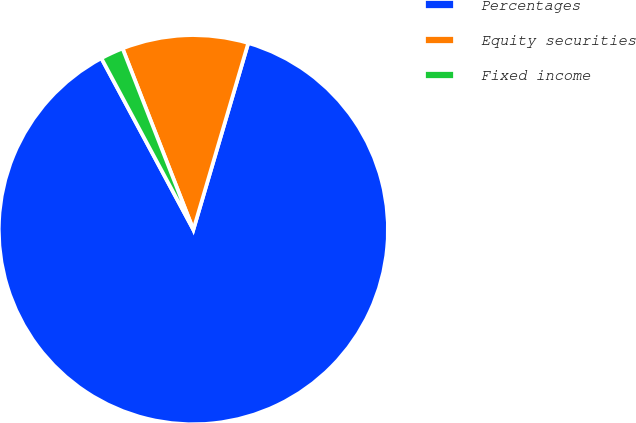Convert chart to OTSL. <chart><loc_0><loc_0><loc_500><loc_500><pie_chart><fcel>Percentages<fcel>Equity securities<fcel>Fixed income<nl><fcel>87.6%<fcel>10.48%<fcel>1.91%<nl></chart> 